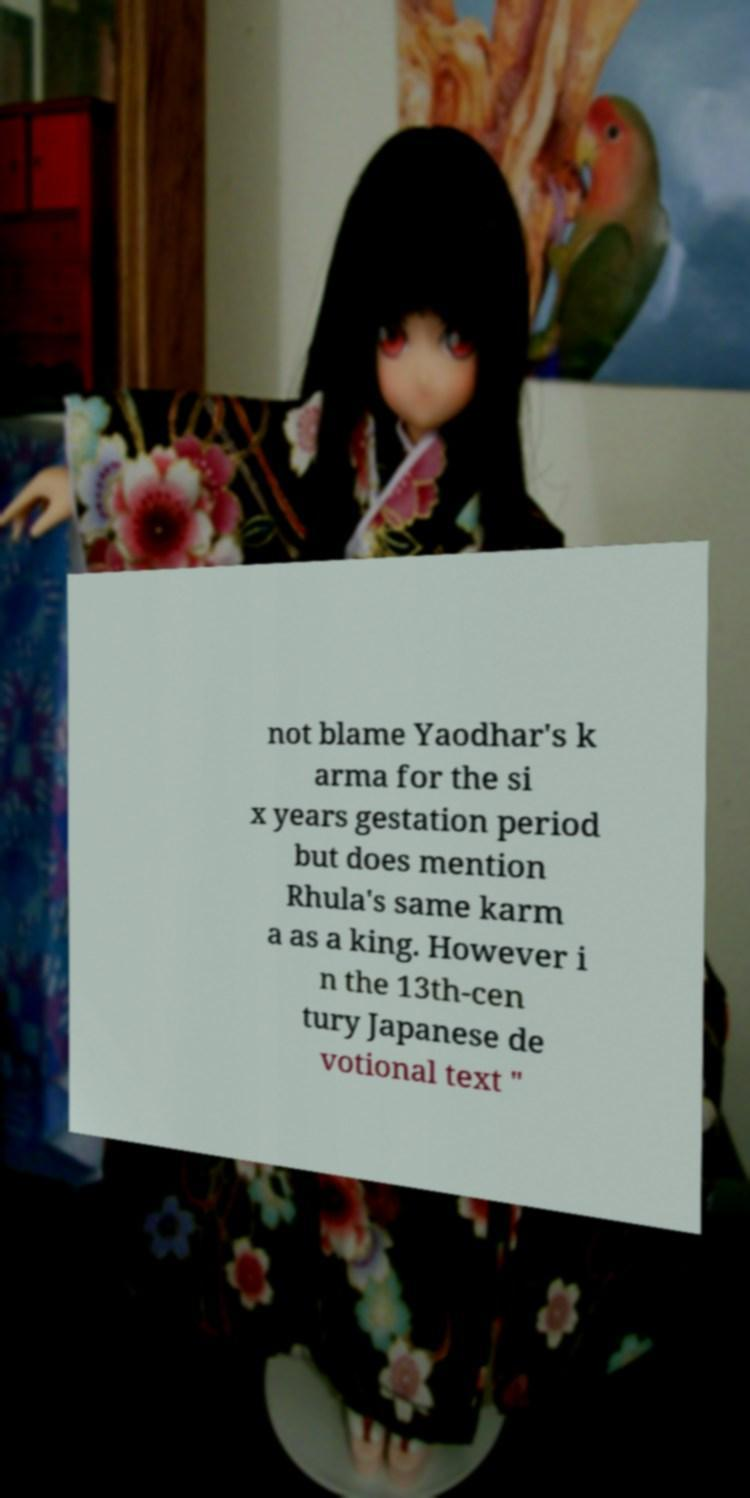Please identify and transcribe the text found in this image. not blame Yaodhar's k arma for the si x years gestation period but does mention Rhula's same karm a as a king. However i n the 13th-cen tury Japanese de votional text " 